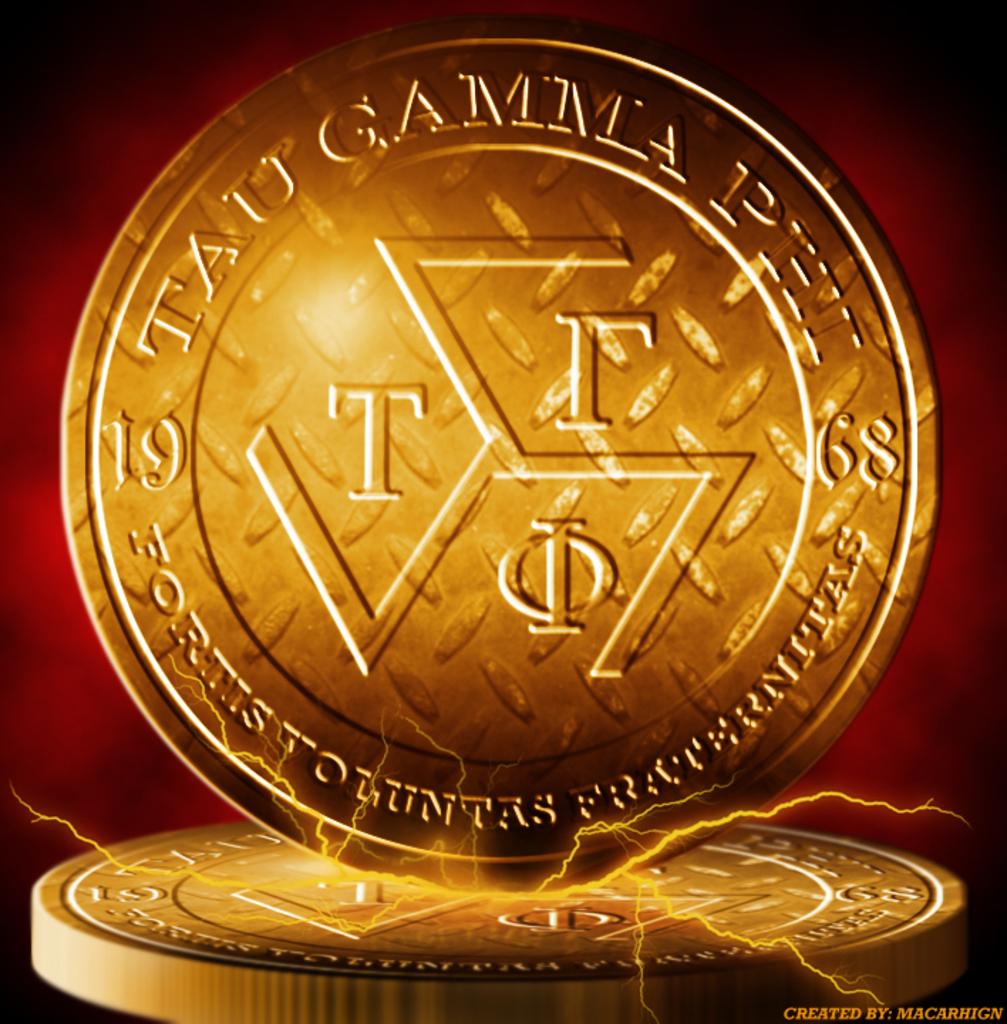What year was this coin minted?
Your answer should be very brief. 1968. 